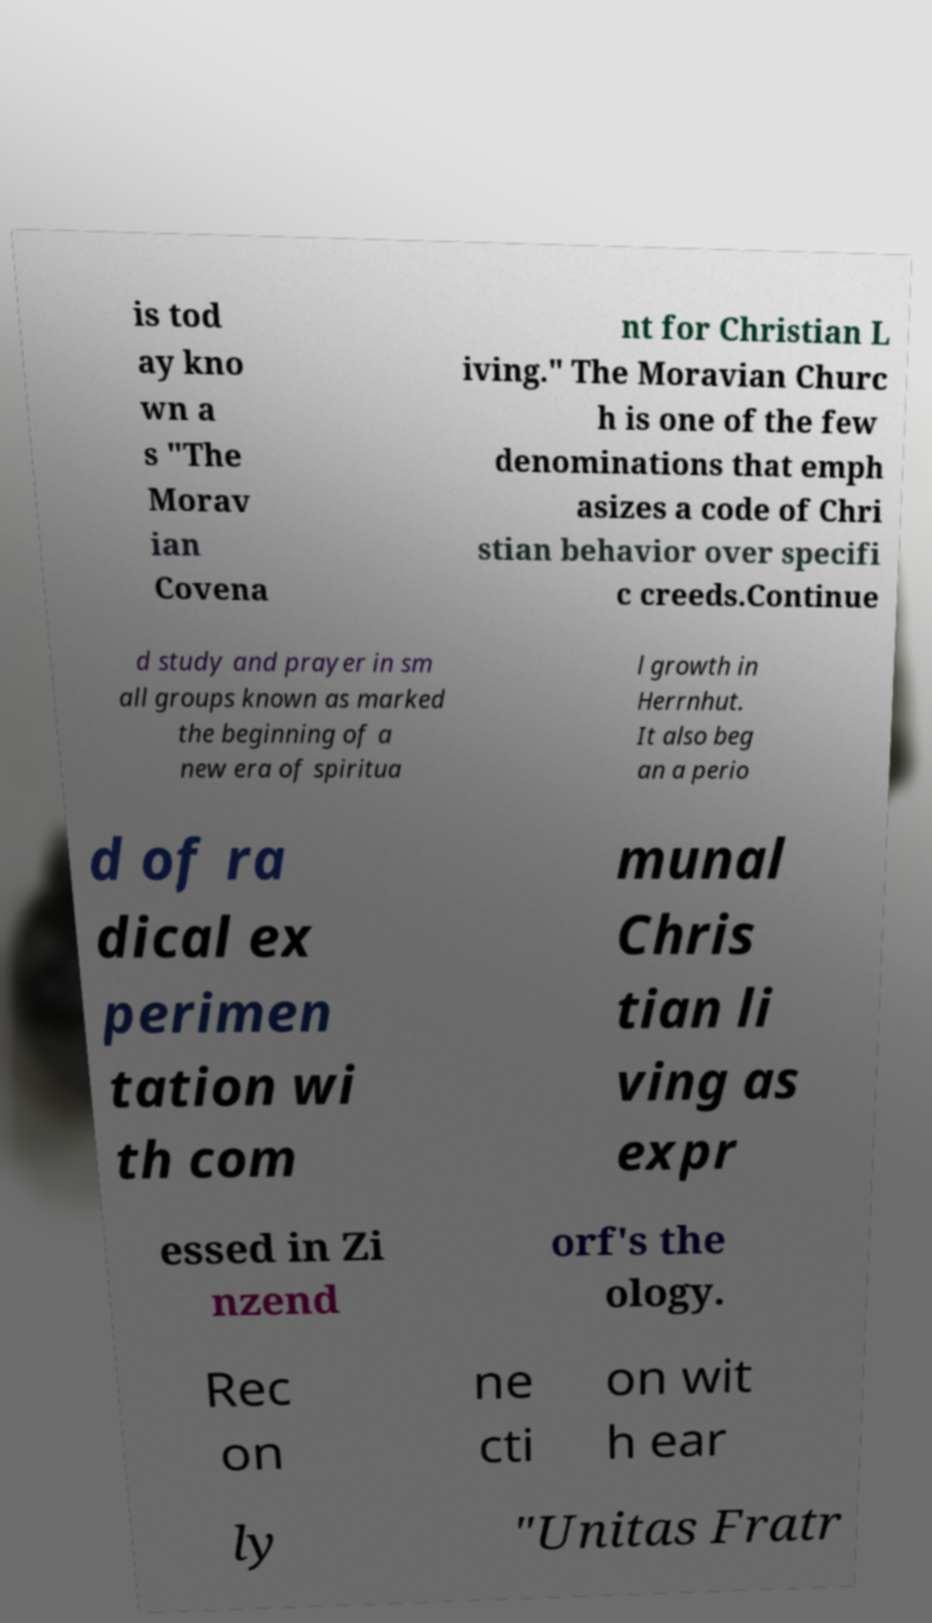What messages or text are displayed in this image? I need them in a readable, typed format. is tod ay kno wn a s "The Morav ian Covena nt for Christian L iving." The Moravian Churc h is one of the few denominations that emph asizes a code of Chri stian behavior over specifi c creeds.Continue d study and prayer in sm all groups known as marked the beginning of a new era of spiritua l growth in Herrnhut. It also beg an a perio d of ra dical ex perimen tation wi th com munal Chris tian li ving as expr essed in Zi nzend orf's the ology. Rec on ne cti on wit h ear ly "Unitas Fratr 